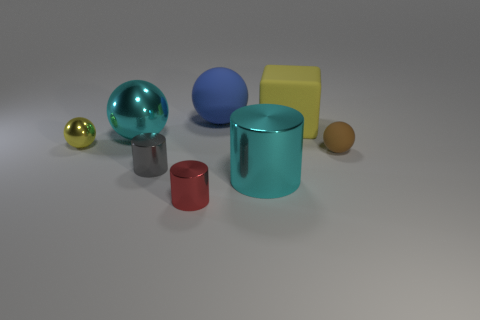Subtract all tiny yellow balls. How many balls are left? 3 Add 1 tiny green metal cylinders. How many objects exist? 9 Subtract all cyan balls. How many balls are left? 3 Subtract all yellow cylinders. Subtract all brown balls. How many cylinders are left? 3 Subtract all gray shiny cylinders. Subtract all big yellow rubber objects. How many objects are left? 6 Add 1 yellow balls. How many yellow balls are left? 2 Add 3 cyan metallic cylinders. How many cyan metallic cylinders exist? 4 Subtract 0 green cylinders. How many objects are left? 8 Subtract all cylinders. How many objects are left? 5 